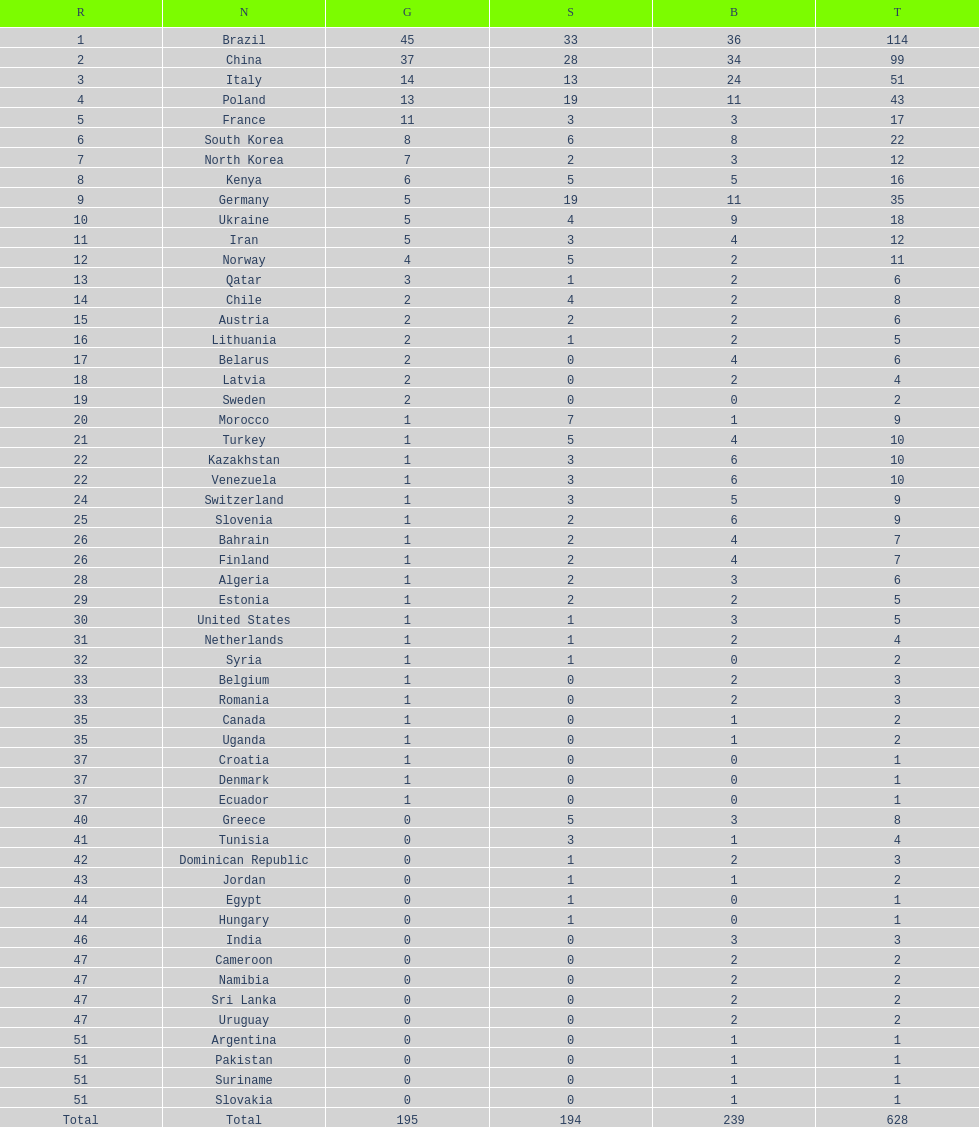Who only won 13 silver medals? Italy. 